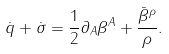<formula> <loc_0><loc_0><loc_500><loc_500>\dot { q } + \dot { \sigma } = \frac { 1 } { 2 } \partial _ { A } \beta ^ { A } + \frac { \bar { \beta } ^ { \rho } } { \rho } .</formula> 